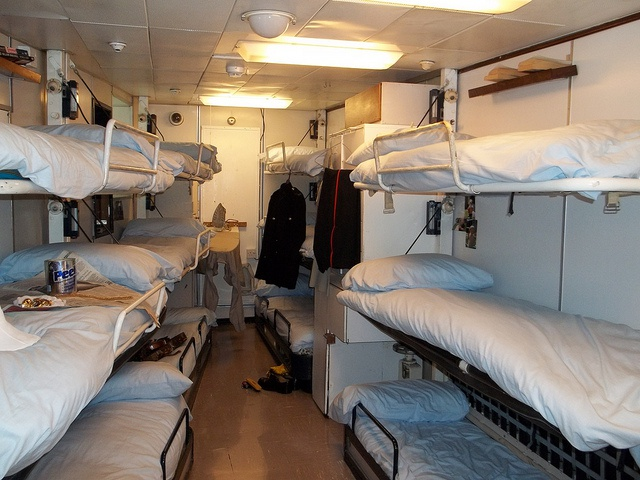Describe the objects in this image and their specific colors. I can see bed in gray, darkgray, tan, and lightgray tones, bed in gray, darkgray, and lightgray tones, bed in gray, lightgray, tan, and darkgray tones, bed in gray and darkgray tones, and bed in gray, darkgray, tan, and lightgray tones in this image. 